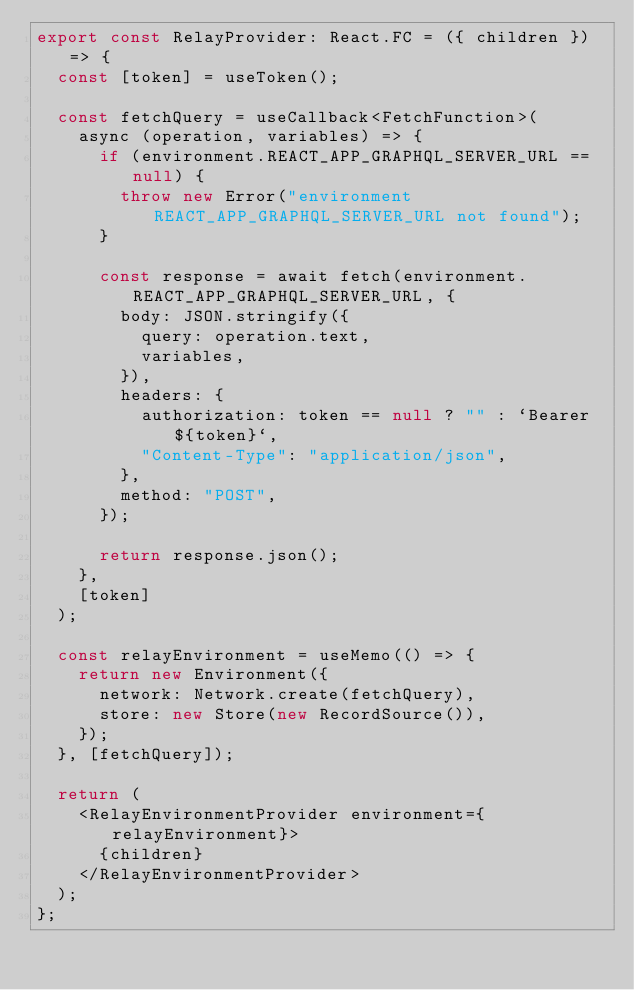<code> <loc_0><loc_0><loc_500><loc_500><_TypeScript_>export const RelayProvider: React.FC = ({ children }) => {
  const [token] = useToken();

  const fetchQuery = useCallback<FetchFunction>(
    async (operation, variables) => {
      if (environment.REACT_APP_GRAPHQL_SERVER_URL == null) {
        throw new Error("environment REACT_APP_GRAPHQL_SERVER_URL not found");
      }

      const response = await fetch(environment.REACT_APP_GRAPHQL_SERVER_URL, {
        body: JSON.stringify({
          query: operation.text,
          variables,
        }),
        headers: {
          authorization: token == null ? "" : `Bearer ${token}`,
          "Content-Type": "application/json",
        },
        method: "POST",
      });

      return response.json();
    },
    [token]
  );

  const relayEnvironment = useMemo(() => {
    return new Environment({
      network: Network.create(fetchQuery),
      store: new Store(new RecordSource()),
    });
  }, [fetchQuery]);

  return (
    <RelayEnvironmentProvider environment={relayEnvironment}>
      {children}
    </RelayEnvironmentProvider>
  );
};
</code> 